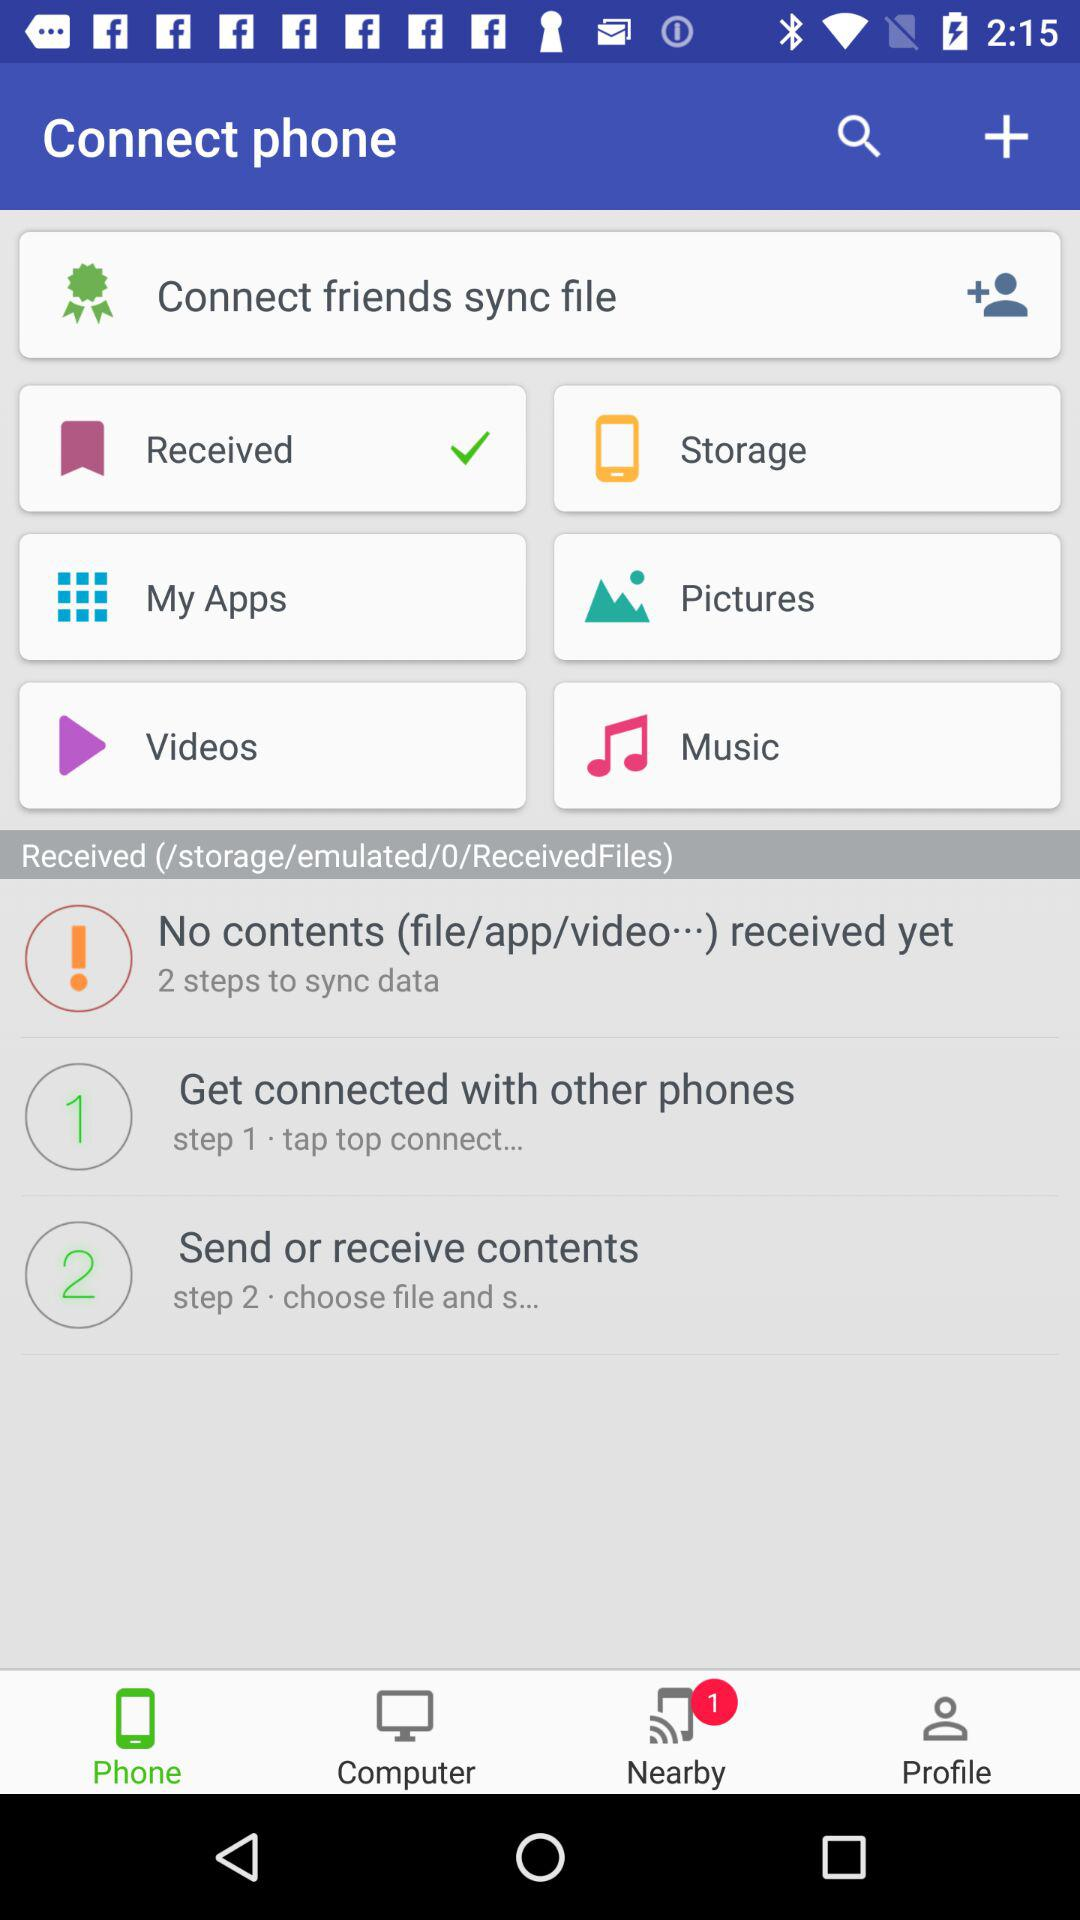How many steps are there to sync data?
Answer the question using a single word or phrase. 2 